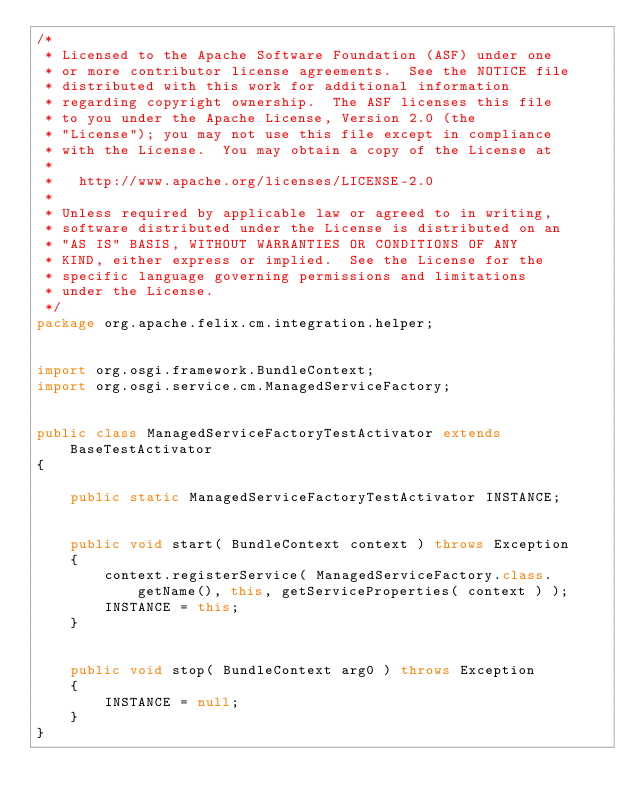<code> <loc_0><loc_0><loc_500><loc_500><_Java_>/*
 * Licensed to the Apache Software Foundation (ASF) under one
 * or more contributor license agreements.  See the NOTICE file
 * distributed with this work for additional information
 * regarding copyright ownership.  The ASF licenses this file
 * to you under the Apache License, Version 2.0 (the
 * "License"); you may not use this file except in compliance
 * with the License.  You may obtain a copy of the License at
 *
 *   http://www.apache.org/licenses/LICENSE-2.0
 *
 * Unless required by applicable law or agreed to in writing,
 * software distributed under the License is distributed on an
 * "AS IS" BASIS, WITHOUT WARRANTIES OR CONDITIONS OF ANY
 * KIND, either express or implied.  See the License for the
 * specific language governing permissions and limitations
 * under the License.
 */
package org.apache.felix.cm.integration.helper;


import org.osgi.framework.BundleContext;
import org.osgi.service.cm.ManagedServiceFactory;


public class ManagedServiceFactoryTestActivator extends BaseTestActivator
{

    public static ManagedServiceFactoryTestActivator INSTANCE;


    public void start( BundleContext context ) throws Exception
    {
        context.registerService( ManagedServiceFactory.class.getName(), this, getServiceProperties( context ) );
        INSTANCE = this;
    }


    public void stop( BundleContext arg0 ) throws Exception
    {
        INSTANCE = null;
    }
}
</code> 